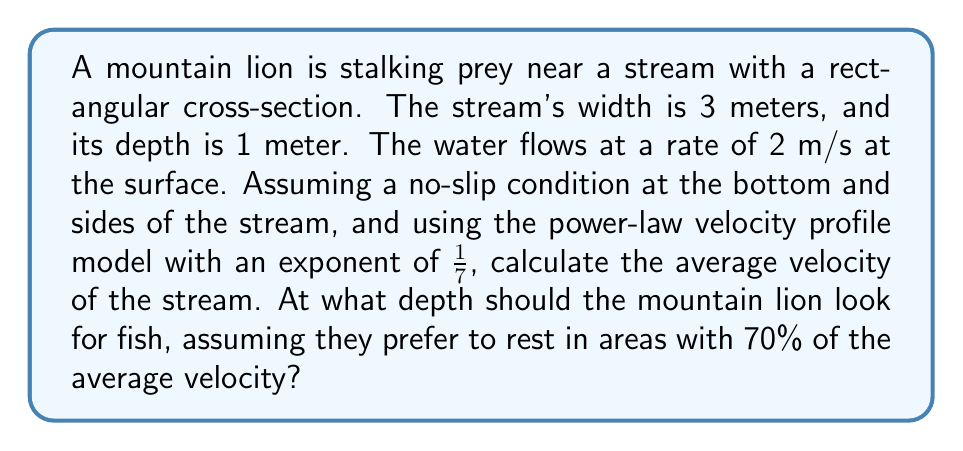What is the answer to this math problem? 1) The power-law velocity profile model is given by:

   $$u(y) = u_{max} \left(\frac{y}{H}\right)^{1/n}$$

   where $u(y)$ is the velocity at height $y$, $u_{max}$ is the maximum velocity (at the surface), $H$ is the total depth, and $n = 7$ for our case.

2) The average velocity can be found by integrating the velocity profile:

   $$\bar{u} = \frac{1}{H} \int_0^H u(y) dy = \frac{1}{H} \int_0^H u_{max} \left(\frac{y}{H}\right)^{1/7} dy$$

3) Solving this integral:

   $$\bar{u} = \frac{u_{max}}{H} \cdot \frac{H \cdot (y/H)^{8/7}}{8/7} \bigg|_0^H = u_{max} \cdot \frac{7}{8} = 2 \cdot \frac{7}{8} = 1.75 \text{ m/s}$$

4) To find the depth where the velocity is 70% of the average:

   $$0.7\bar{u} = u_{max} \left(\frac{y}{H}\right)^{1/7}$$
   $$0.7 \cdot 1.75 = 2 \left(\frac{y}{1}\right)^{1/7}$$
   $$\left(\frac{y}{1}\right)^{1/7} = \frac{0.7 \cdot 1.75}{2} = 0.61250$$
   $$y = (0.61250)^7 \approx 0.0502 \text{ meters}$$

5) The depth from the bottom of the stream is:

   $$1 - 0.0502 = 0.9498 \text{ meters}$$
Answer: Average velocity: 1.75 m/s; Ideal fishing depth: 0.9498 m from bottom 